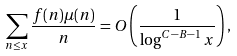Convert formula to latex. <formula><loc_0><loc_0><loc_500><loc_500>\sum _ { n \leq x } \frac { f ( n ) \mu ( n ) } { n } = O \left ( \frac { 1 } { \log ^ { C - B - 1 } x } \right ) ,</formula> 